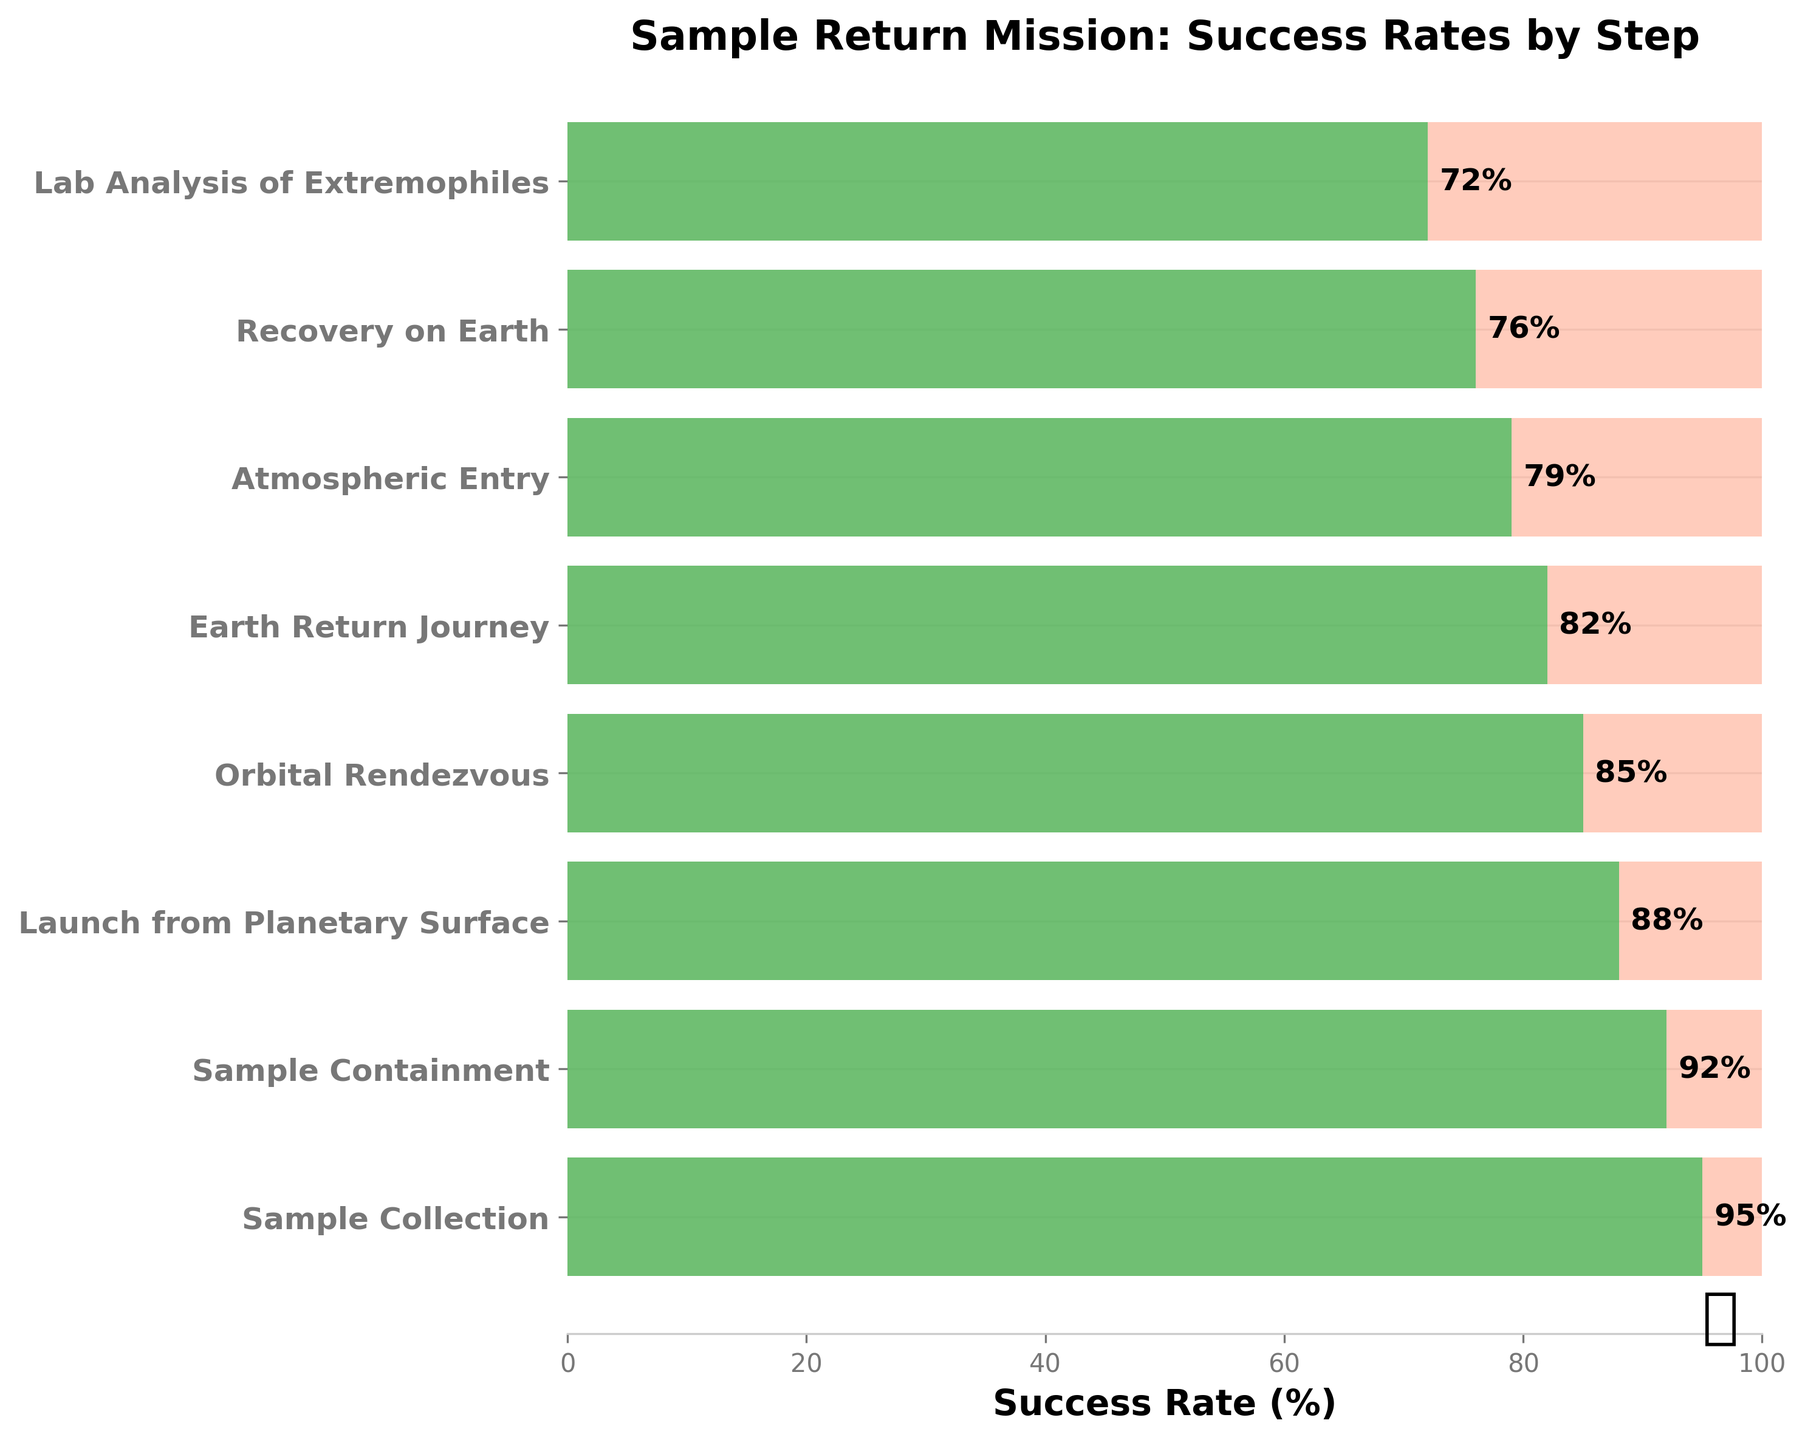What is the success rate for the "Sample Collection" step? The "Sample Collection" step has a success rate percentage displayed next to the bar in the chart. It's labeled as 95%.
Answer: 95% Which step has the lowest success rate? The step with the lowest success rate is the one that has the smallest percentage value next to it. In this case, "Lab Analysis of Extremophiles" is labeled with 72%, which is lower than all other steps.
Answer: Lab Analysis of Extremophiles How many steps have a success rate of 80% or higher? To find how many steps have a success rate of 80% or higher, count all the steps that have success rates 80% or above. Sorting success rates: 95, 92, 88, 85, and 82. This counts as 5 steps.
Answer: 5 What is the difference in success rates between the "Orbital Rendezvous" and "Atmospheric Entry" steps? Subtract the success rate of "Atmospheric Entry" (79%) from "Orbital Rendezvous" (85%). The difference is calculated as 85 - 79 = 6.
Answer: 6% What is the average success rate for all steps? Add the success rates for all steps: 95 + 92 + 88 + 85 + 82 + 79 + 76 + 72 = 669. Then divide by the number of steps, which is 8; 669 / 8 = 83.625.
Answer: 83.625 How much higher is the success rate for "Earth Return Journey" compared to "Recovery on Earth"? Compare the success rates by subtracting "Recovery on Earth" (76%) from "Earth Return Journey" (82%). The difference is 82 - 76 = 6.
Answer: 6% Which step has the third highest success rate? Order the success rates from highest to lowest and pick the third one. The ordered list is 95, 92, 88, 85, 82, 79, 76, 72. The third highest rate is 88%, which corresponds to "Launch from Planetary Surface".
Answer: Launch from Planetary Surface What is the median success rate of the steps? List the success rates in order: 72, 76, 79, 82, 85, 88, 92, 95. As there are 8 steps, the median is the average of the 4th and 5th values: (82 + 85) / 2 = 83.5.
Answer: 83.5 